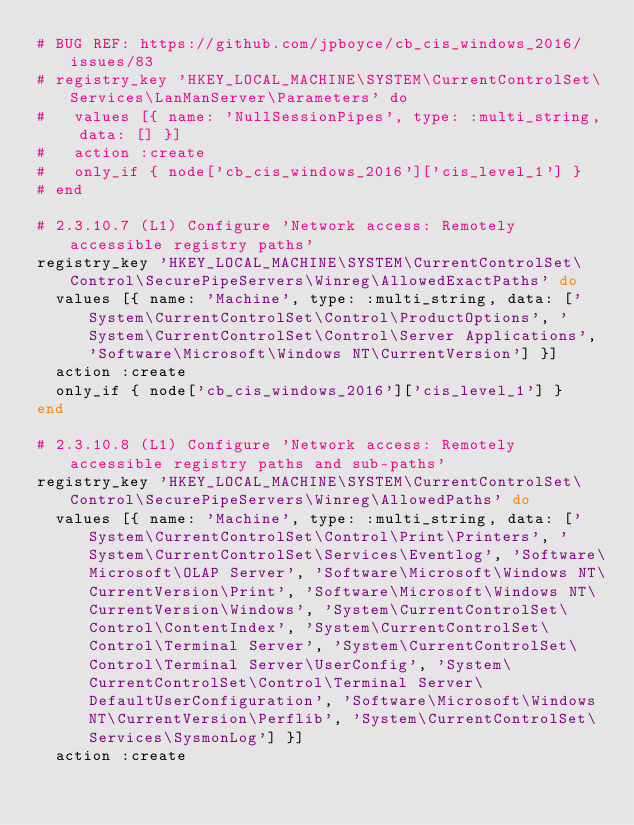Convert code to text. <code><loc_0><loc_0><loc_500><loc_500><_Ruby_># BUG REF: https://github.com/jpboyce/cb_cis_windows_2016/issues/83
# registry_key 'HKEY_LOCAL_MACHINE\SYSTEM\CurrentControlSet\Services\LanManServer\Parameters' do
#   values [{ name: 'NullSessionPipes', type: :multi_string, data: [] }]
#   action :create
#   only_if { node['cb_cis_windows_2016']['cis_level_1'] }
# end

# 2.3.10.7 (L1) Configure 'Network access: Remotely accessible registry paths'
registry_key 'HKEY_LOCAL_MACHINE\SYSTEM\CurrentControlSet\Control\SecurePipeServers\Winreg\AllowedExactPaths' do
  values [{ name: 'Machine', type: :multi_string, data: ['System\CurrentControlSet\Control\ProductOptions', 'System\CurrentControlSet\Control\Server Applications', 'Software\Microsoft\Windows NT\CurrentVersion'] }]
  action :create
  only_if { node['cb_cis_windows_2016']['cis_level_1'] }
end

# 2.3.10.8 (L1) Configure 'Network access: Remotely accessible registry paths and sub-paths'
registry_key 'HKEY_LOCAL_MACHINE\SYSTEM\CurrentControlSet\Control\SecurePipeServers\Winreg\AllowedPaths' do
  values [{ name: 'Machine', type: :multi_string, data: ['System\CurrentControlSet\Control\Print\Printers', 'System\CurrentControlSet\Services\Eventlog', 'Software\Microsoft\OLAP Server', 'Software\Microsoft\Windows NT\CurrentVersion\Print', 'Software\Microsoft\Windows NT\CurrentVersion\Windows', 'System\CurrentControlSet\Control\ContentIndex', 'System\CurrentControlSet\Control\Terminal Server', 'System\CurrentControlSet\Control\Terminal Server\UserConfig', 'System\CurrentControlSet\Control\Terminal Server\DefaultUserConfiguration', 'Software\Microsoft\Windows NT\CurrentVersion\Perflib', 'System\CurrentControlSet\Services\SysmonLog'] }]
  action :create</code> 